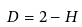<formula> <loc_0><loc_0><loc_500><loc_500>D = 2 - H</formula> 